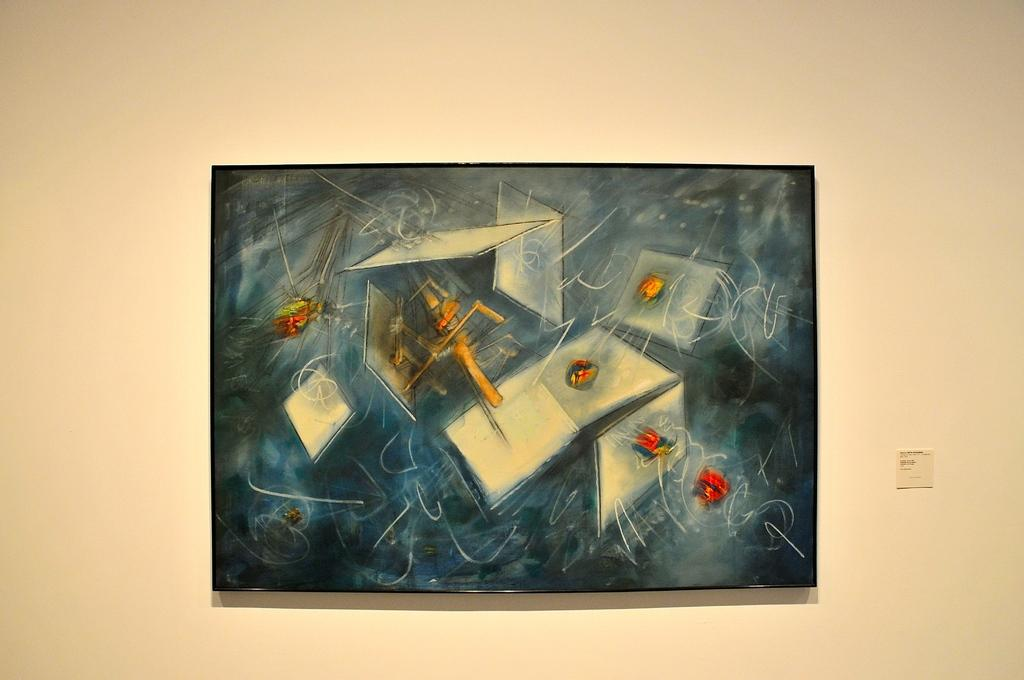What is the main subject in the center of the picture? There is a painting in the center of the picture. Where is the painting located? The painting is on a wall. What color is the wall on which the painting is hung? The wall is painted in white color. How many chickens are depicted in the painting? There is no information about the content of the painting, so we cannot determine if there are any chickens depicted. 